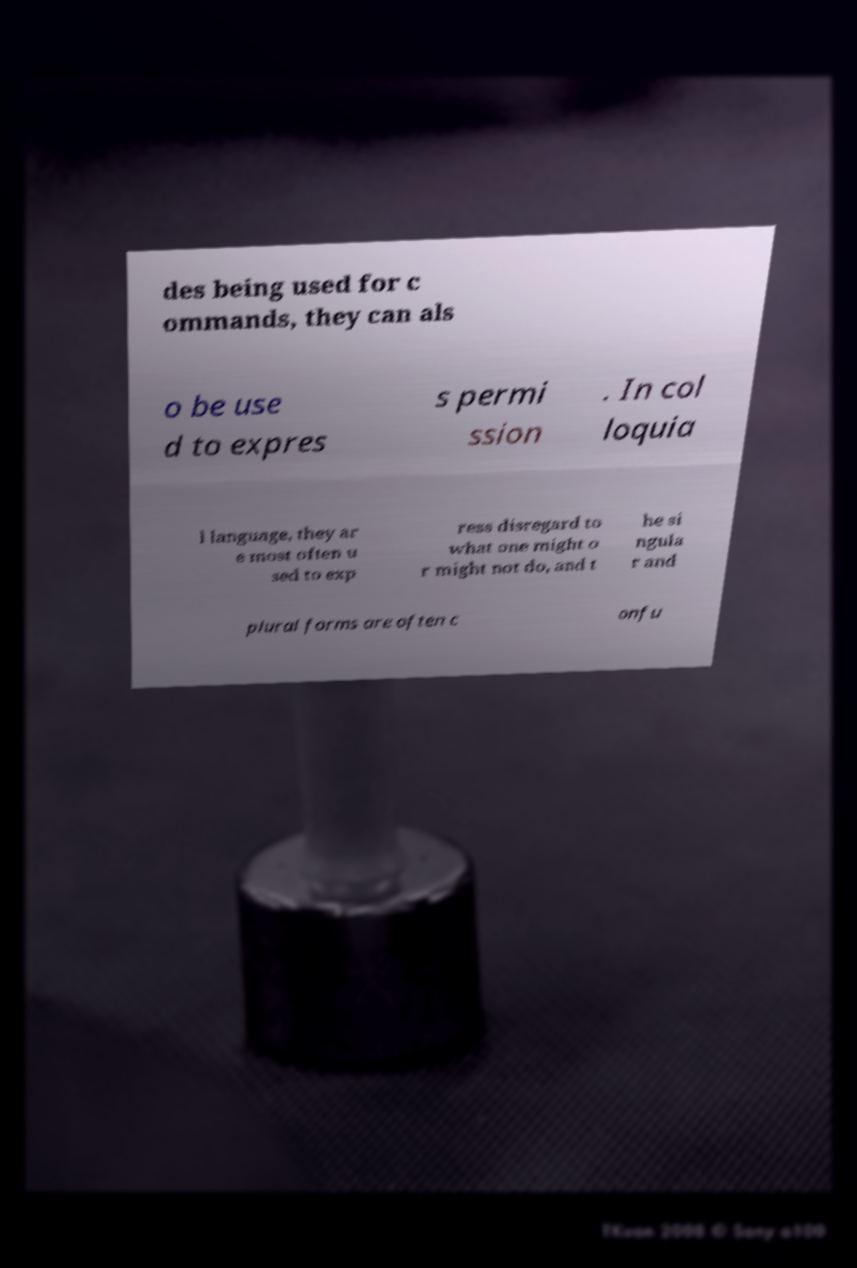Please identify and transcribe the text found in this image. des being used for c ommands, they can als o be use d to expres s permi ssion . In col loquia l language, they ar e most often u sed to exp ress disregard to what one might o r might not do, and t he si ngula r and plural forms are often c onfu 